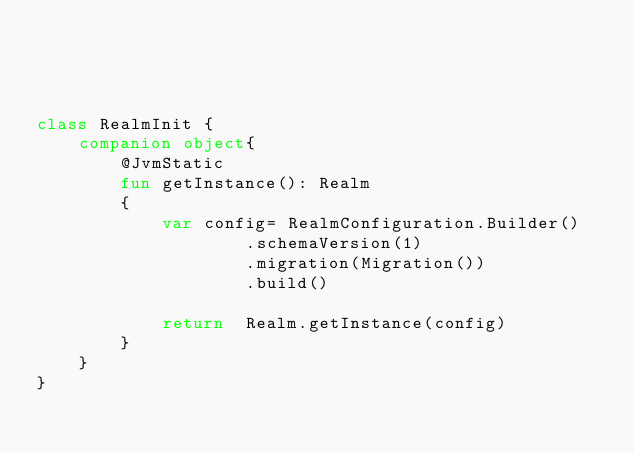Convert code to text. <code><loc_0><loc_0><loc_500><loc_500><_Kotlin_>



class RealmInit {
    companion object{
        @JvmStatic
        fun getInstance(): Realm
        {
            var config= RealmConfiguration.Builder()
                    .schemaVersion(1)
                    .migration(Migration())
                    .build()

            return  Realm.getInstance(config)
        }
    }
}</code> 